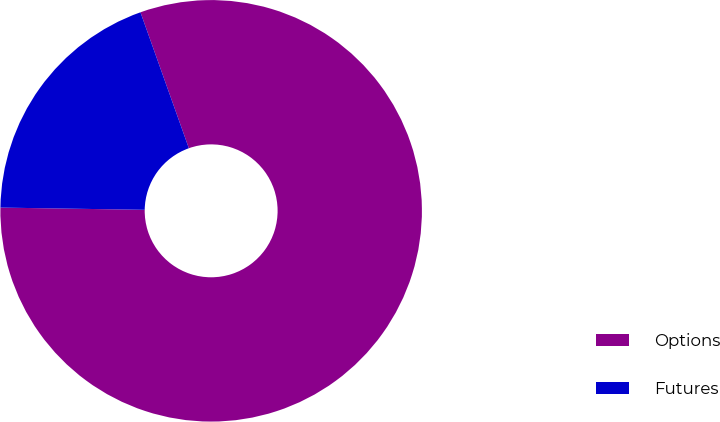Convert chart to OTSL. <chart><loc_0><loc_0><loc_500><loc_500><pie_chart><fcel>Options<fcel>Futures<nl><fcel>80.69%<fcel>19.31%<nl></chart> 